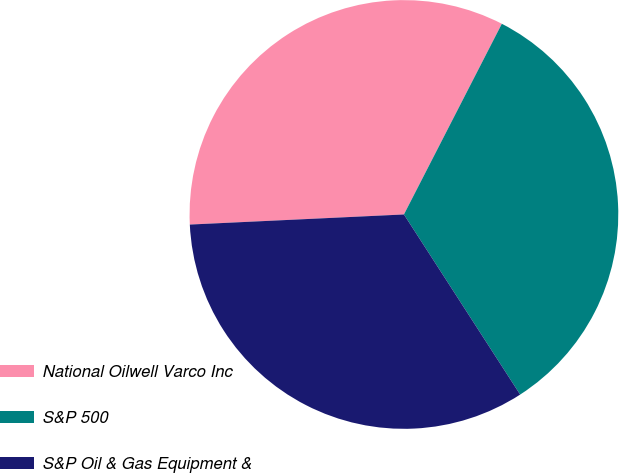<chart> <loc_0><loc_0><loc_500><loc_500><pie_chart><fcel>National Oilwell Varco Inc<fcel>S&P 500<fcel>S&P Oil & Gas Equipment &<nl><fcel>33.3%<fcel>33.33%<fcel>33.37%<nl></chart> 